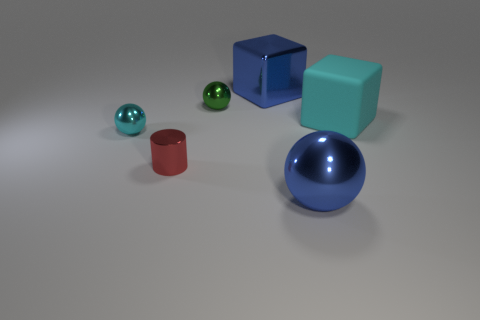Add 1 cyan things. How many objects exist? 7 Subtract all cubes. How many objects are left? 4 Add 2 shiny spheres. How many shiny spheres are left? 5 Add 5 big cyan metal balls. How many big cyan metal balls exist? 5 Subtract 0 purple balls. How many objects are left? 6 Subtract all red balls. Subtract all tiny metallic cylinders. How many objects are left? 5 